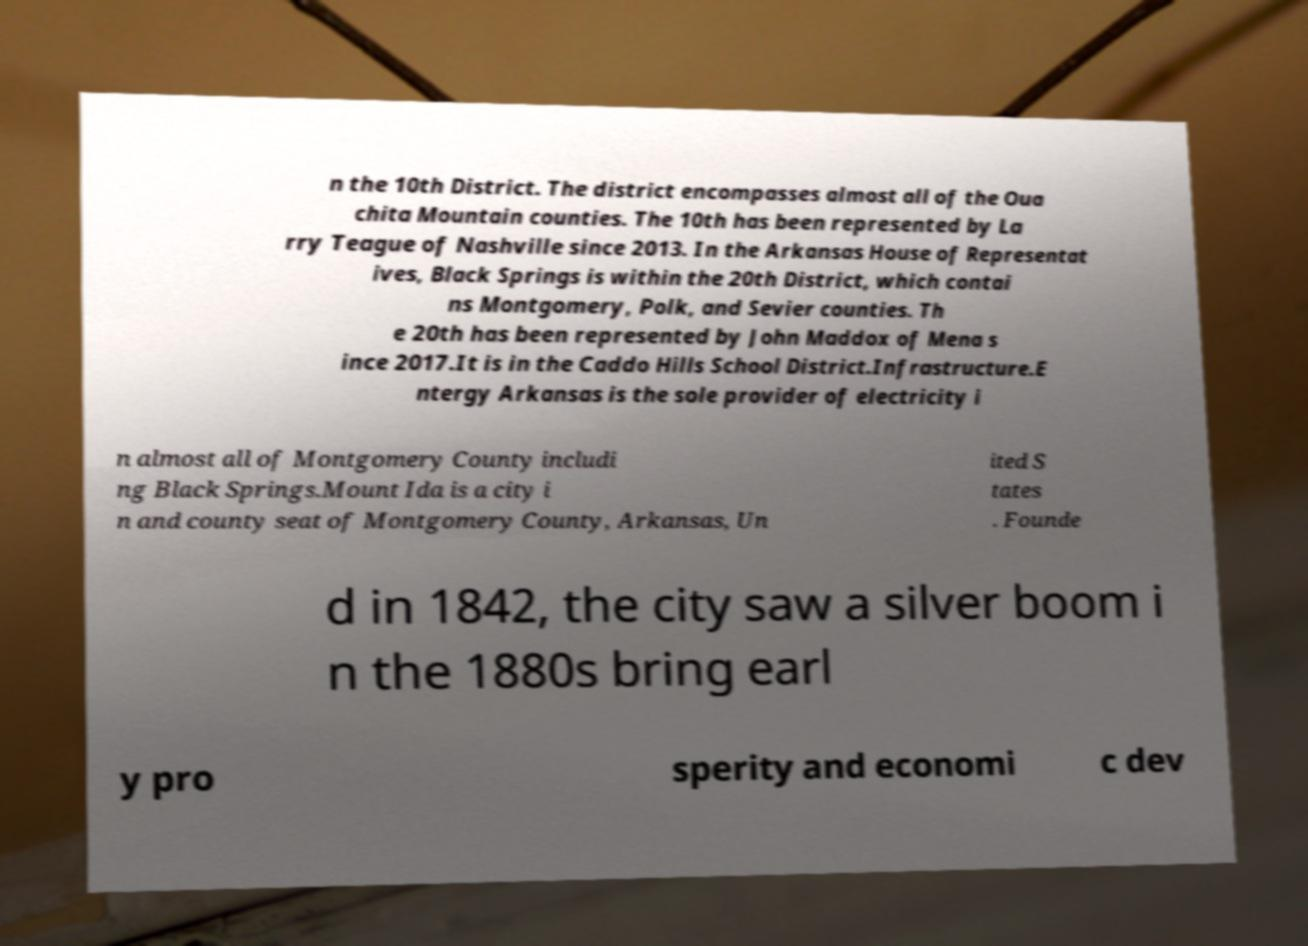I need the written content from this picture converted into text. Can you do that? n the 10th District. The district encompasses almost all of the Oua chita Mountain counties. The 10th has been represented by La rry Teague of Nashville since 2013. In the Arkansas House of Representat ives, Black Springs is within the 20th District, which contai ns Montgomery, Polk, and Sevier counties. Th e 20th has been represented by John Maddox of Mena s ince 2017.It is in the Caddo Hills School District.Infrastructure.E ntergy Arkansas is the sole provider of electricity i n almost all of Montgomery County includi ng Black Springs.Mount Ida is a city i n and county seat of Montgomery County, Arkansas, Un ited S tates . Founde d in 1842, the city saw a silver boom i n the 1880s bring earl y pro sperity and economi c dev 